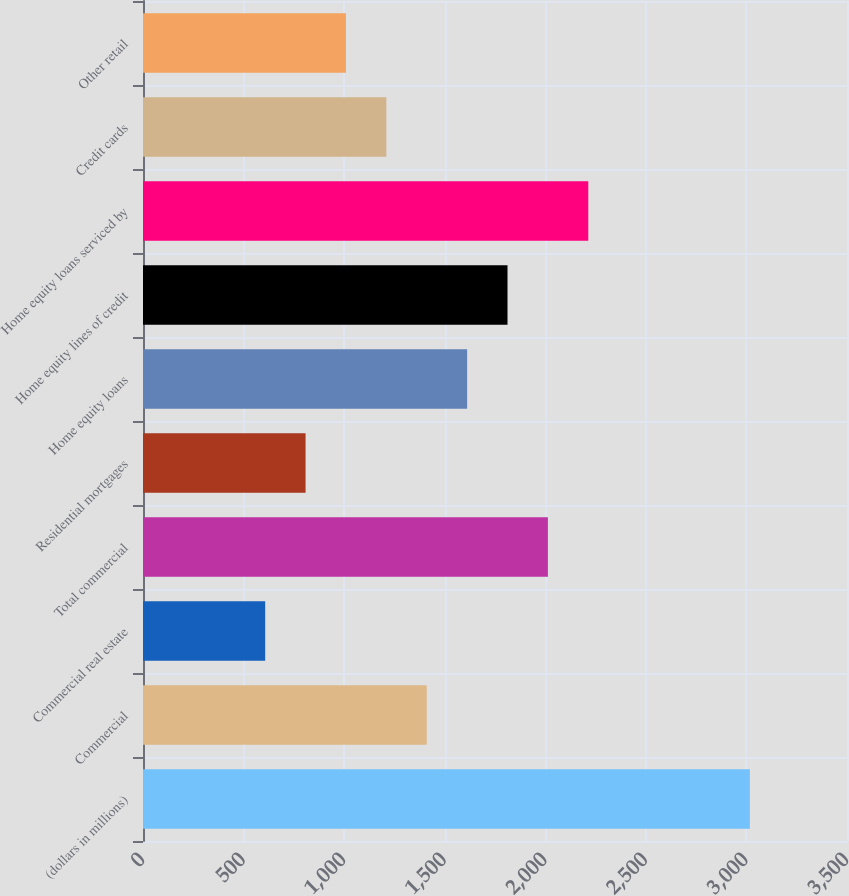Convert chart to OTSL. <chart><loc_0><loc_0><loc_500><loc_500><bar_chart><fcel>(dollars in millions)<fcel>Commercial<fcel>Commercial real estate<fcel>Total commercial<fcel>Residential mortgages<fcel>Home equity loans<fcel>Home equity lines of credit<fcel>Home equity loans serviced by<fcel>Credit cards<fcel>Other retail<nl><fcel>3017<fcel>1410.6<fcel>607.4<fcel>2013<fcel>808.2<fcel>1611.4<fcel>1812.2<fcel>2213.8<fcel>1209.8<fcel>1009<nl></chart> 